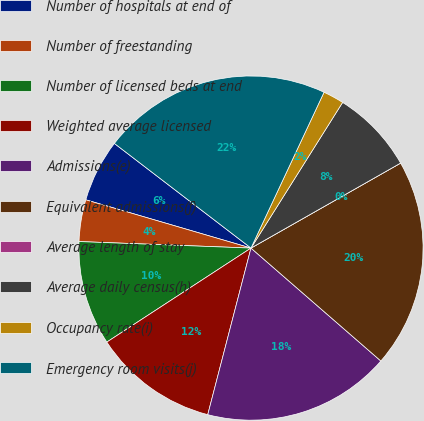Convert chart. <chart><loc_0><loc_0><loc_500><loc_500><pie_chart><fcel>Number of hospitals at end of<fcel>Number of freestanding<fcel>Number of licensed beds at end<fcel>Weighted average licensed<fcel>Admissions(e)<fcel>Equivalent admissions(f)<fcel>Average length of stay<fcel>Average daily census(h)<fcel>Occupancy rate(i)<fcel>Emergency room visits(j)<nl><fcel>5.88%<fcel>3.92%<fcel>9.8%<fcel>11.76%<fcel>17.65%<fcel>19.61%<fcel>0.0%<fcel>7.84%<fcel>1.96%<fcel>21.57%<nl></chart> 